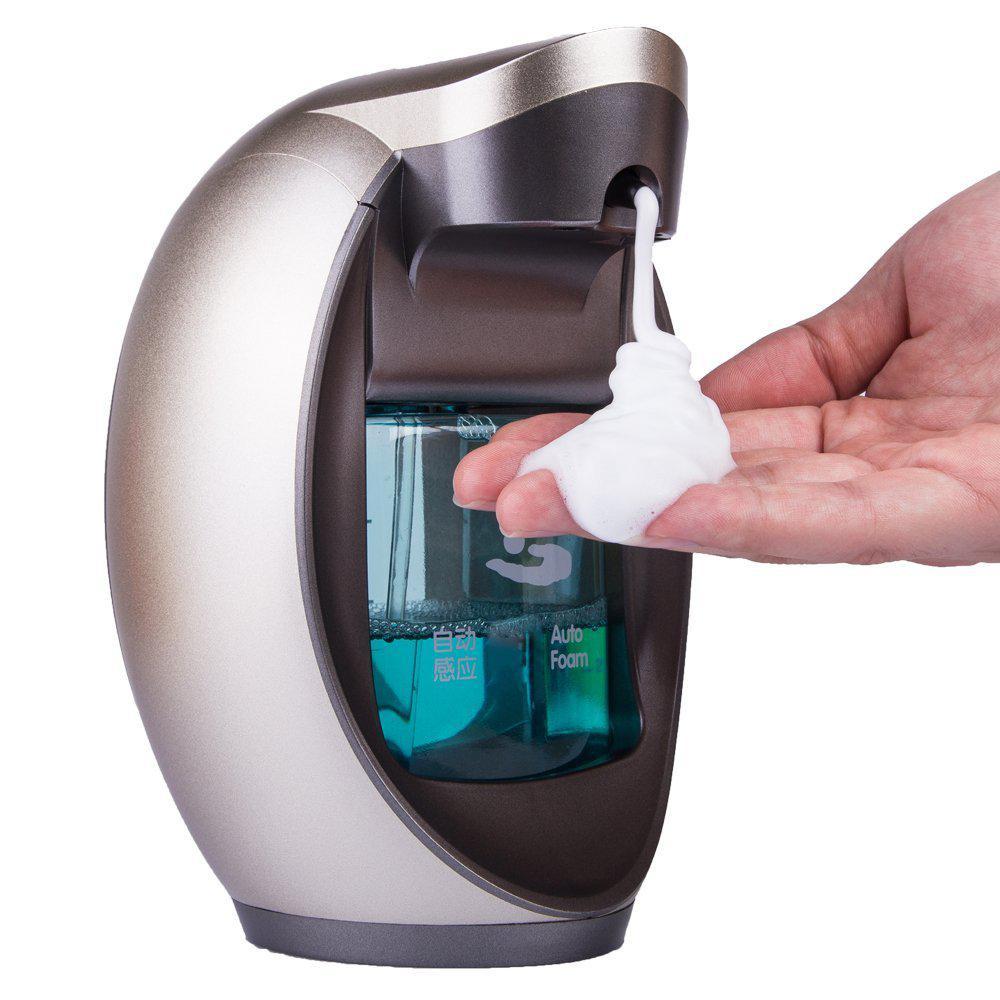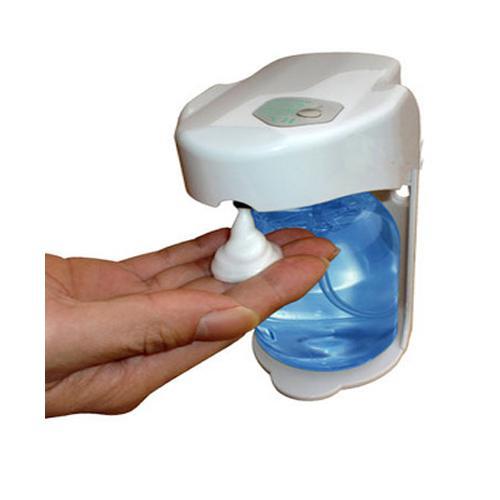The first image is the image on the left, the second image is the image on the right. Assess this claim about the two images: "The image on the right contains a human hand.". Correct or not? Answer yes or no. Yes. 